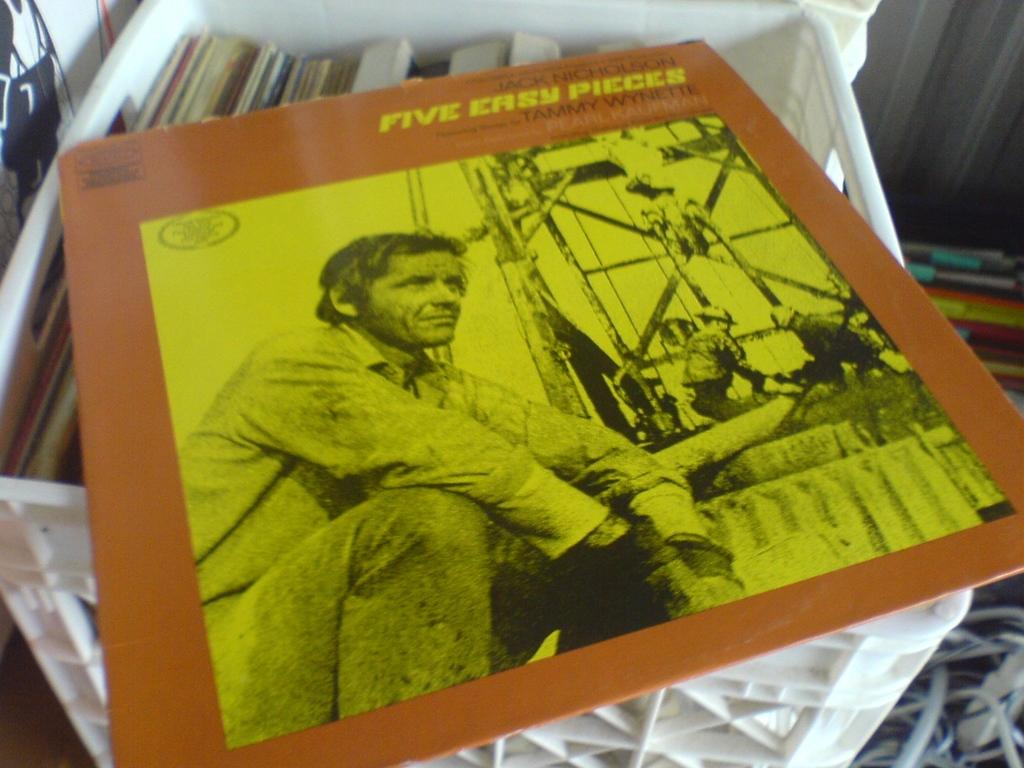<image>
Summarize the visual content of the image. A Jack Nicholson movie called Five Easy Pieces features songs by Tammy Wynette. 